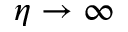Convert formula to latex. <formula><loc_0><loc_0><loc_500><loc_500>\eta \to \infty</formula> 